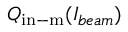<formula> <loc_0><loc_0><loc_500><loc_500>Q _ { i n - m } ( I _ { b e a m } )</formula> 